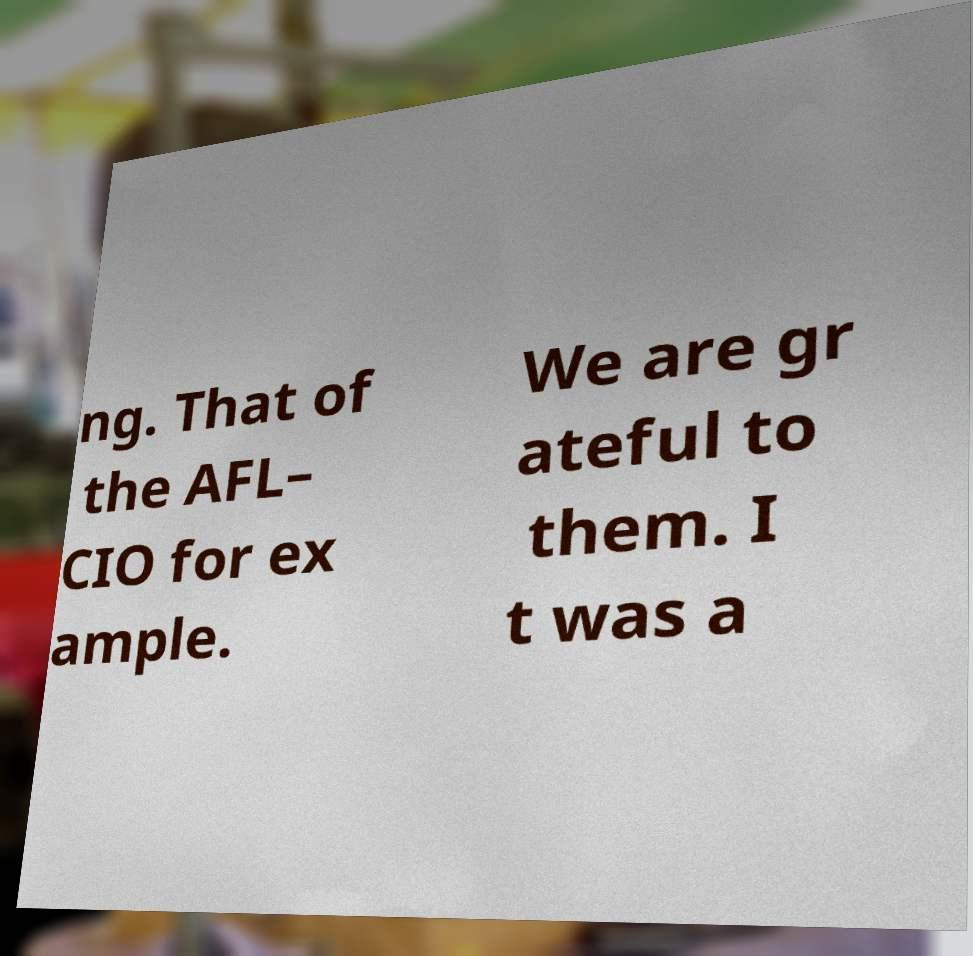Please read and relay the text visible in this image. What does it say? ng. That of the AFL– CIO for ex ample. We are gr ateful to them. I t was a 